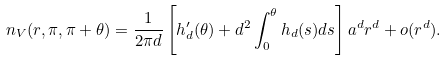Convert formula to latex. <formula><loc_0><loc_0><loc_500><loc_500>n _ { V } ( r , \pi , \pi + \theta ) = \frac { 1 } { 2 \pi d } \left [ h _ { d } ^ { \prime } ( \theta ) + d ^ { 2 } \int _ { 0 } ^ { \theta } h _ { d } ( s ) d s \right ] a ^ { d } r ^ { d } + o ( r ^ { d } ) .</formula> 